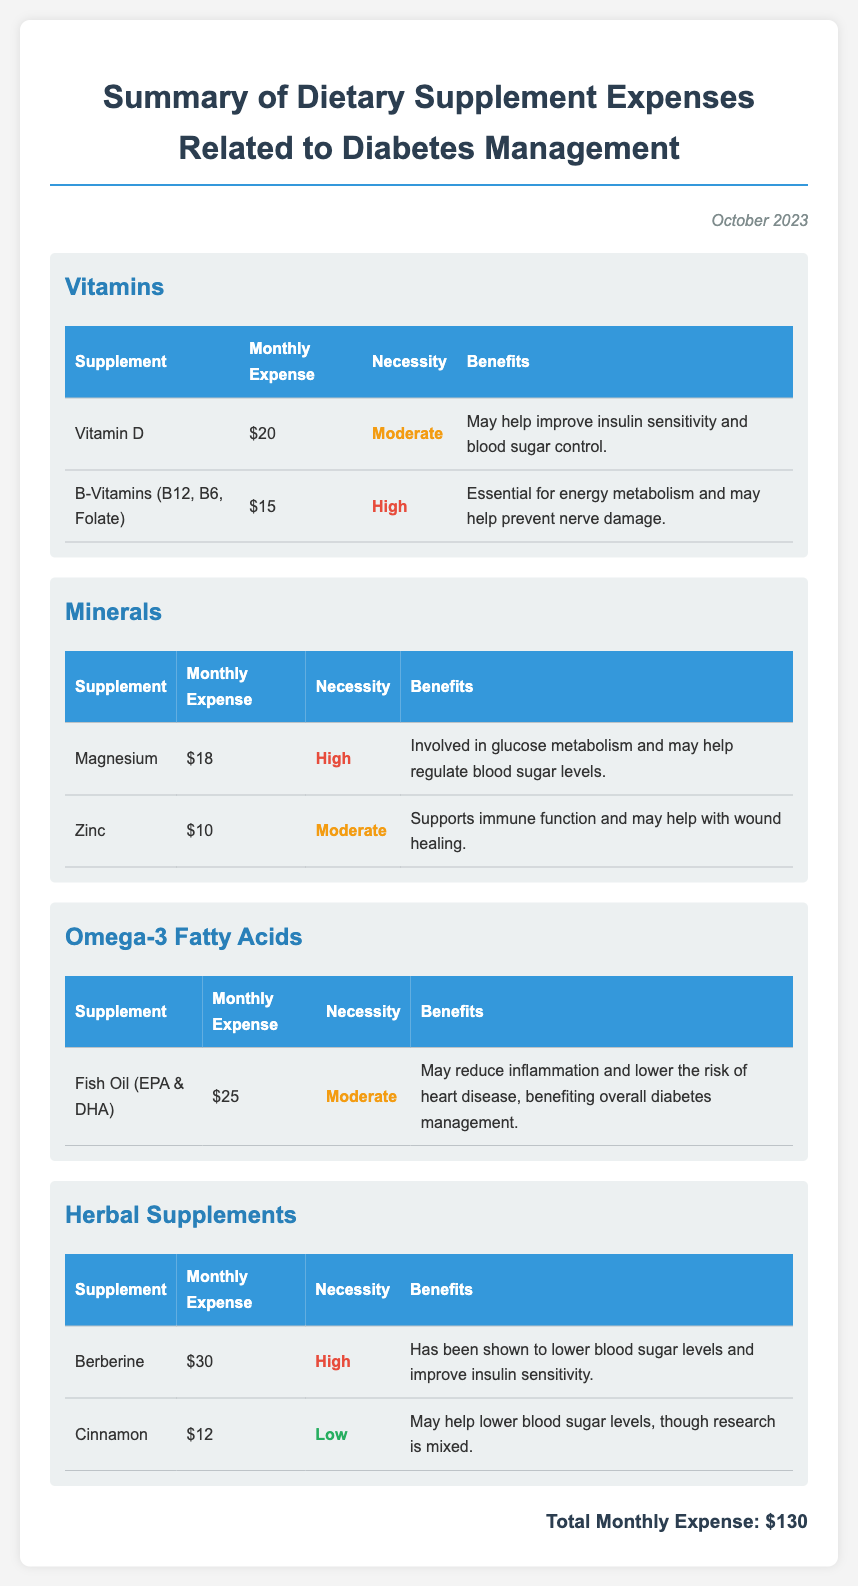what is the total monthly expense? The total monthly expense is listed at the end of the report as the sum of all dietary supplement expenses.
Answer: $130 what is the necessity level of Vitamin D? The necessity level of Vitamin D is categorized as Moderate in the Vitamins section of the report.
Answer: Moderate how much is spent on B-Vitamins each month? The monthly expense for B-Vitamins (B12, B6, Folate) is noted in the Vitamins table.
Answer: $15 which supplement is noted for lowering blood sugar levels? Berberine is specifically mentioned in the Herbal Supplements section for its ability to lower blood sugar levels.
Answer: Berberine how much does fish oil (EPA & DHA) cost per month? The cost of fish oil (EPA & DHA) is provided in the Omega-3 Fatty Acids section of the document.
Answer: $25 what category does Zinc fall under? Zinc is categorized under Minerals in the expense report.
Answer: Minerals which supplement has a necessity level rated as High but is also the most expensive? The supplement that is rated as High in necessity and has the highest cost is Berberine at $30 per month.
Answer: Berberine what benefit is associated with Magnesium? The reported benefit of Magnesium is that it is involved in glucose metabolism and may help regulate blood sugar levels.
Answer: Regulate blood sugar levels how many types of dietary supplements are listed in the report? The report lists four types of dietary supplements related to diabetes management.
Answer: Four 